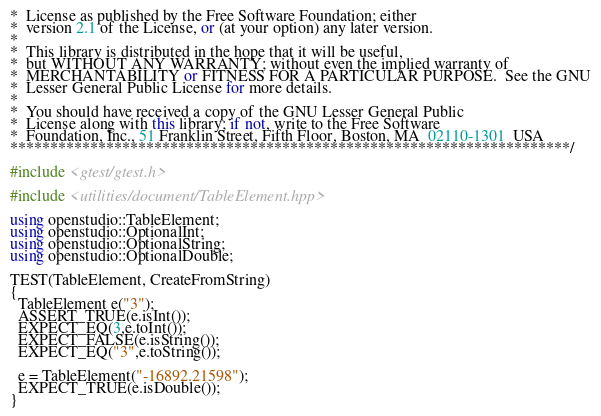<code> <loc_0><loc_0><loc_500><loc_500><_C++_>*  License as published by the Free Software Foundation; either
*  version 2.1 of the License, or (at your option) any later version.
*
*  This library is distributed in the hope that it will be useful,
*  but WITHOUT ANY WARRANTY; without even the implied warranty of
*  MERCHANTABILITY or FITNESS FOR A PARTICULAR PURPOSE.  See the GNU
*  Lesser General Public License for more details.
*
*  You should have received a copy of the GNU Lesser General Public
*  License along with this library; if not, write to the Free Software
*  Foundation, Inc., 51 Franklin Street, Fifth Floor, Boston, MA  02110-1301  USA
**********************************************************************/

#include <gtest/gtest.h>

#include <utilities/document/TableElement.hpp>

using openstudio::TableElement;
using openstudio::OptionalInt;
using openstudio::OptionalString;
using openstudio::OptionalDouble;

TEST(TableElement, CreateFromString)
{
  TableElement e("3");
  ASSERT_TRUE(e.isInt());
  EXPECT_EQ(3,e.toInt());
  EXPECT_FALSE(e.isString());
  EXPECT_EQ("3",e.toString());

  e = TableElement("-16892.21598");
  EXPECT_TRUE(e.isDouble());
}
</code> 